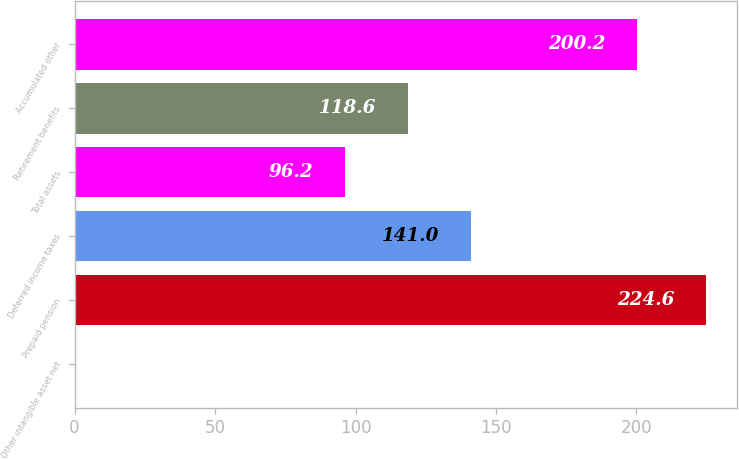Convert chart to OTSL. <chart><loc_0><loc_0><loc_500><loc_500><bar_chart><fcel>Other intangible asset net<fcel>Prepaid pension<fcel>Deferred income taxes<fcel>Total assets<fcel>Retirement benefits<fcel>Accumulated other<nl><fcel>0.6<fcel>224.6<fcel>141<fcel>96.2<fcel>118.6<fcel>200.2<nl></chart> 